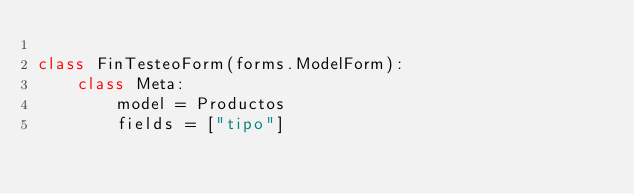Convert code to text. <code><loc_0><loc_0><loc_500><loc_500><_Python_>
class FinTesteoForm(forms.ModelForm):
    class Meta:
        model = Productos
        fields = ["tipo"]
</code> 